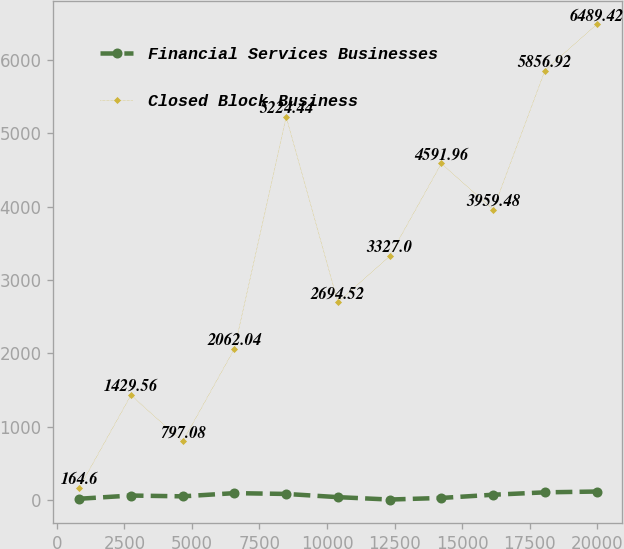Convert chart. <chart><loc_0><loc_0><loc_500><loc_500><line_chart><ecel><fcel>Financial Services Businesses<fcel>Closed Block Business<nl><fcel>831.49<fcel>15.29<fcel>164.6<nl><fcel>2745.8<fcel>59.01<fcel>1429.56<nl><fcel>4660.11<fcel>48.08<fcel>797.08<nl><fcel>6574.42<fcel>91.8<fcel>2062.04<nl><fcel>8488.73<fcel>80.87<fcel>5224.44<nl><fcel>10403<fcel>37.15<fcel>2694.52<nl><fcel>12317.4<fcel>4.36<fcel>3327<nl><fcel>14231.7<fcel>26.22<fcel>4591.96<nl><fcel>16146<fcel>69.94<fcel>3959.48<nl><fcel>18060.3<fcel>102.73<fcel>5856.92<nl><fcel>19974.6<fcel>113.66<fcel>6489.42<nl></chart> 